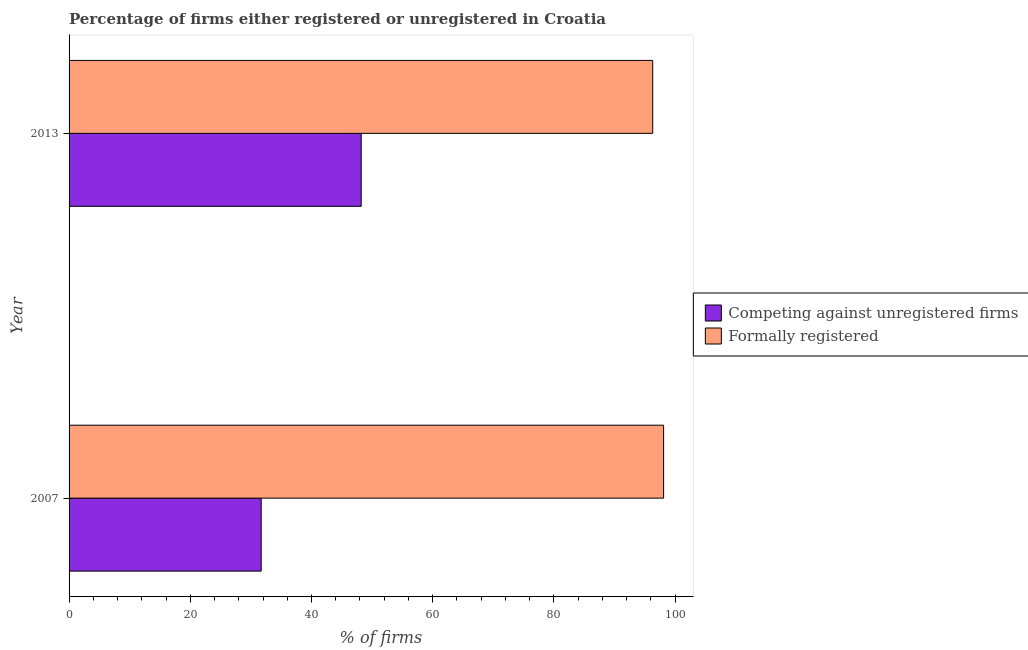How many groups of bars are there?
Ensure brevity in your answer.  2. Are the number of bars on each tick of the Y-axis equal?
Provide a succinct answer. Yes. How many bars are there on the 1st tick from the top?
Make the answer very short. 2. In how many cases, is the number of bars for a given year not equal to the number of legend labels?
Ensure brevity in your answer.  0. What is the percentage of formally registered firms in 2007?
Make the answer very short. 98.1. Across all years, what is the maximum percentage of formally registered firms?
Provide a short and direct response. 98.1. Across all years, what is the minimum percentage of registered firms?
Offer a terse response. 31.7. In which year was the percentage of formally registered firms minimum?
Provide a short and direct response. 2013. What is the total percentage of registered firms in the graph?
Provide a short and direct response. 79.9. What is the difference between the percentage of registered firms in 2007 and that in 2013?
Your answer should be compact. -16.5. What is the difference between the percentage of registered firms in 2013 and the percentage of formally registered firms in 2007?
Keep it short and to the point. -49.9. What is the average percentage of registered firms per year?
Offer a terse response. 39.95. In the year 2007, what is the difference between the percentage of registered firms and percentage of formally registered firms?
Your answer should be compact. -66.4. In how many years, is the percentage of registered firms greater than 28 %?
Provide a short and direct response. 2. What is the ratio of the percentage of registered firms in 2007 to that in 2013?
Offer a terse response. 0.66. Is the difference between the percentage of registered firms in 2007 and 2013 greater than the difference between the percentage of formally registered firms in 2007 and 2013?
Your answer should be very brief. No. In how many years, is the percentage of registered firms greater than the average percentage of registered firms taken over all years?
Keep it short and to the point. 1. What does the 1st bar from the top in 2007 represents?
Make the answer very short. Formally registered. What does the 2nd bar from the bottom in 2007 represents?
Your answer should be compact. Formally registered. How many bars are there?
Offer a terse response. 4. Does the graph contain grids?
Provide a succinct answer. No. How many legend labels are there?
Your answer should be compact. 2. What is the title of the graph?
Your response must be concise. Percentage of firms either registered or unregistered in Croatia. Does "Private funds" appear as one of the legend labels in the graph?
Provide a short and direct response. No. What is the label or title of the X-axis?
Your answer should be compact. % of firms. What is the label or title of the Y-axis?
Your response must be concise. Year. What is the % of firms in Competing against unregistered firms in 2007?
Provide a succinct answer. 31.7. What is the % of firms in Formally registered in 2007?
Keep it short and to the point. 98.1. What is the % of firms of Competing against unregistered firms in 2013?
Offer a terse response. 48.2. What is the % of firms of Formally registered in 2013?
Provide a short and direct response. 96.3. Across all years, what is the maximum % of firms in Competing against unregistered firms?
Offer a very short reply. 48.2. Across all years, what is the maximum % of firms of Formally registered?
Make the answer very short. 98.1. Across all years, what is the minimum % of firms in Competing against unregistered firms?
Ensure brevity in your answer.  31.7. Across all years, what is the minimum % of firms in Formally registered?
Your answer should be very brief. 96.3. What is the total % of firms of Competing against unregistered firms in the graph?
Your response must be concise. 79.9. What is the total % of firms in Formally registered in the graph?
Ensure brevity in your answer.  194.4. What is the difference between the % of firms in Competing against unregistered firms in 2007 and that in 2013?
Keep it short and to the point. -16.5. What is the difference between the % of firms in Competing against unregistered firms in 2007 and the % of firms in Formally registered in 2013?
Ensure brevity in your answer.  -64.6. What is the average % of firms in Competing against unregistered firms per year?
Give a very brief answer. 39.95. What is the average % of firms in Formally registered per year?
Keep it short and to the point. 97.2. In the year 2007, what is the difference between the % of firms of Competing against unregistered firms and % of firms of Formally registered?
Make the answer very short. -66.4. In the year 2013, what is the difference between the % of firms in Competing against unregistered firms and % of firms in Formally registered?
Offer a terse response. -48.1. What is the ratio of the % of firms of Competing against unregistered firms in 2007 to that in 2013?
Offer a very short reply. 0.66. What is the ratio of the % of firms of Formally registered in 2007 to that in 2013?
Offer a terse response. 1.02. What is the difference between the highest and the second highest % of firms in Formally registered?
Ensure brevity in your answer.  1.8. What is the difference between the highest and the lowest % of firms of Competing against unregistered firms?
Make the answer very short. 16.5. 